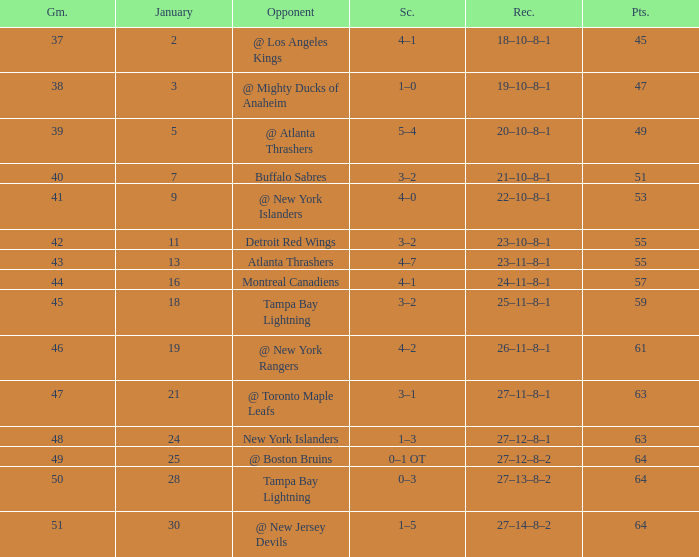Would you mind parsing the complete table? {'header': ['Gm.', 'January', 'Opponent', 'Sc.', 'Rec.', 'Pts.'], 'rows': [['37', '2', '@ Los Angeles Kings', '4–1', '18–10–8–1', '45'], ['38', '3', '@ Mighty Ducks of Anaheim', '1–0', '19–10–8–1', '47'], ['39', '5', '@ Atlanta Thrashers', '5–4', '20–10–8–1', '49'], ['40', '7', 'Buffalo Sabres', '3–2', '21–10–8–1', '51'], ['41', '9', '@ New York Islanders', '4–0', '22–10–8–1', '53'], ['42', '11', 'Detroit Red Wings', '3–2', '23–10–8–1', '55'], ['43', '13', 'Atlanta Thrashers', '4–7', '23–11–8–1', '55'], ['44', '16', 'Montreal Canadiens', '4–1', '24–11–8–1', '57'], ['45', '18', 'Tampa Bay Lightning', '3–2', '25–11–8–1', '59'], ['46', '19', '@ New York Rangers', '4–2', '26–11–8–1', '61'], ['47', '21', '@ Toronto Maple Leafs', '3–1', '27–11–8–1', '63'], ['48', '24', 'New York Islanders', '1–3', '27–12–8–1', '63'], ['49', '25', '@ Boston Bruins', '0–1 OT', '27–12–8–2', '64'], ['50', '28', 'Tampa Bay Lightning', '0–3', '27–13–8–2', '64'], ['51', '30', '@ New Jersey Devils', '1–5', '27–14–8–2', '64']]} Which Points have a Score of 4–1, and a Record of 18–10–8–1, and a January larger than 2? None. 